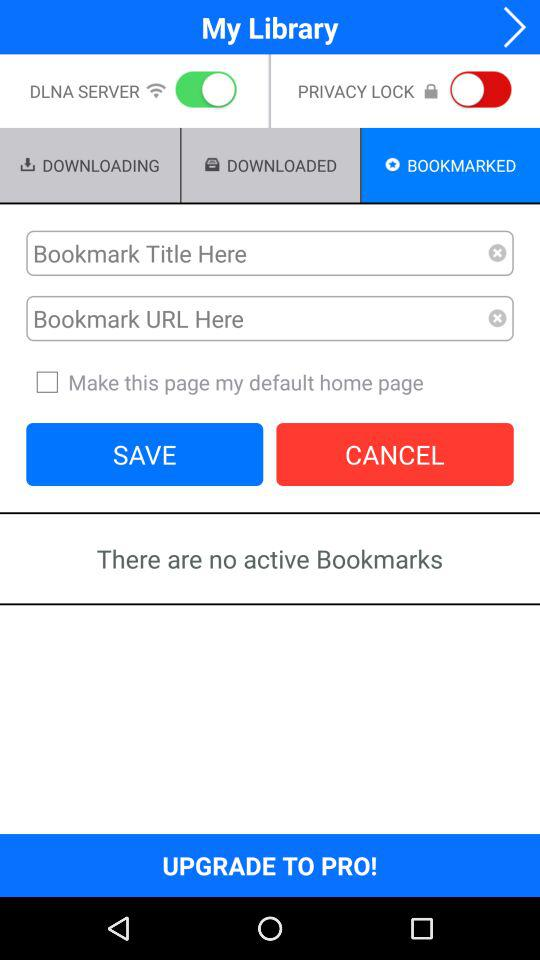What is the current status of the "DLNA SERVER" setting? The current status of the "DLNA SERVER" setting is "on". 